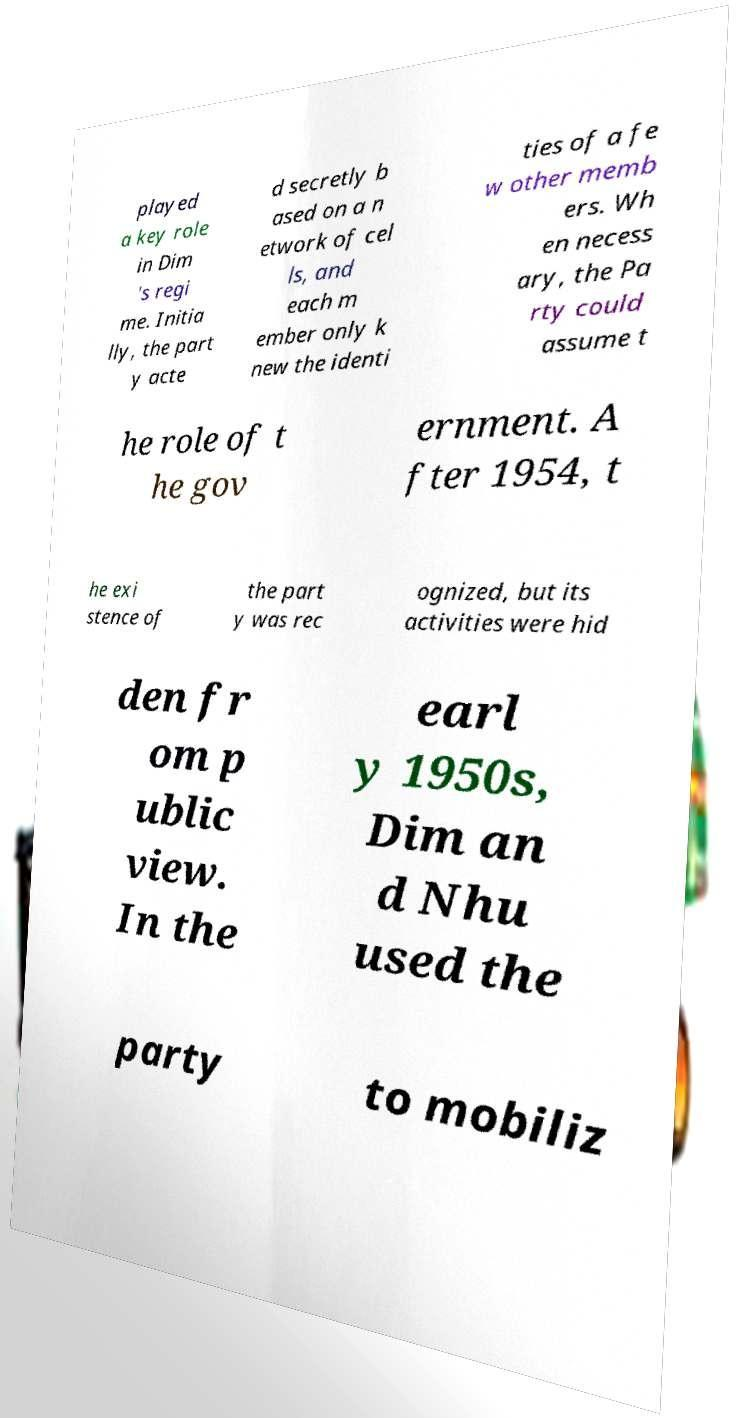Please read and relay the text visible in this image. What does it say? played a key role in Dim 's regi me. Initia lly, the part y acte d secretly b ased on a n etwork of cel ls, and each m ember only k new the identi ties of a fe w other memb ers. Wh en necess ary, the Pa rty could assume t he role of t he gov ernment. A fter 1954, t he exi stence of the part y was rec ognized, but its activities were hid den fr om p ublic view. In the earl y 1950s, Dim an d Nhu used the party to mobiliz 